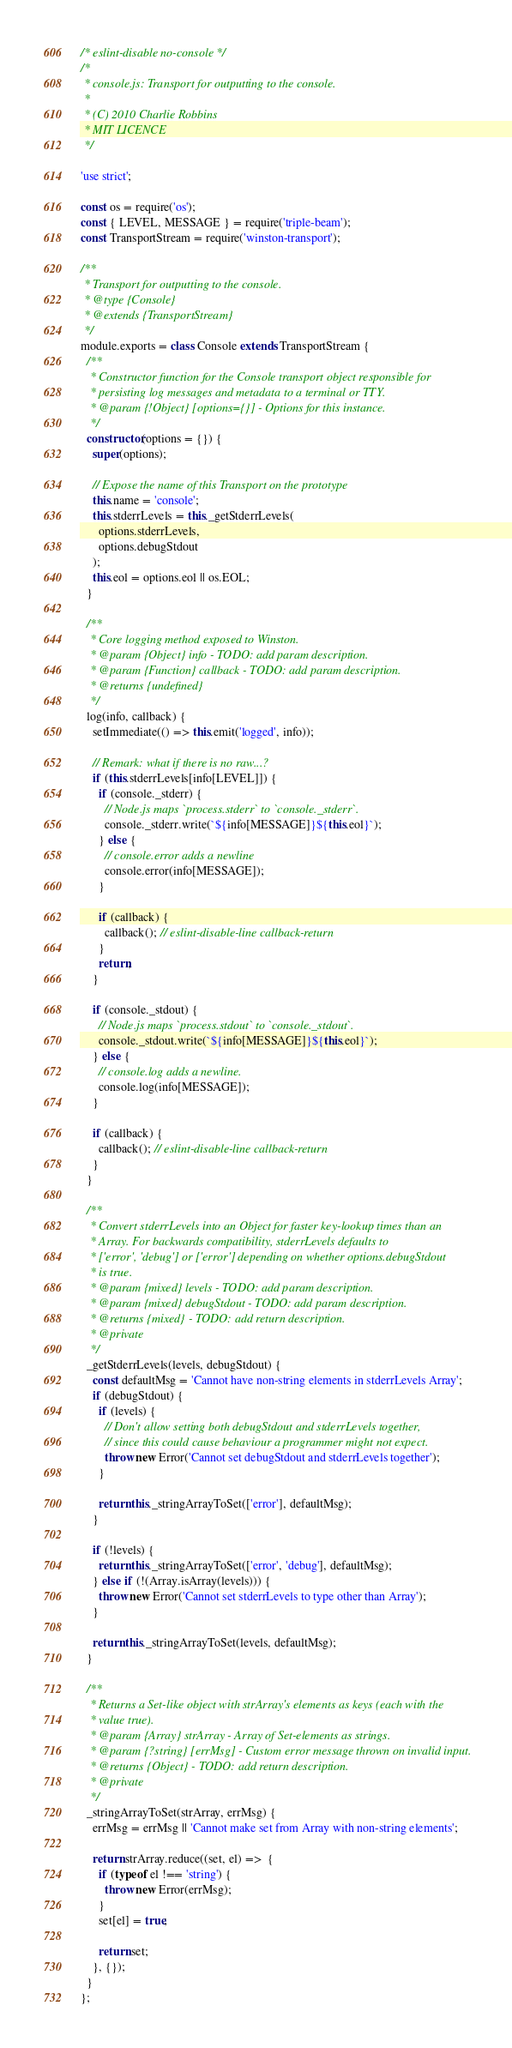<code> <loc_0><loc_0><loc_500><loc_500><_JavaScript_>/* eslint-disable no-console */
/*
 * console.js: Transport for outputting to the console.
 *
 * (C) 2010 Charlie Robbins
 * MIT LICENCE
 */

'use strict';

const os = require('os');
const { LEVEL, MESSAGE } = require('triple-beam');
const TransportStream = require('winston-transport');

/**
 * Transport for outputting to the console.
 * @type {Console}
 * @extends {TransportStream}
 */
module.exports = class Console extends TransportStream {
  /**
   * Constructor function for the Console transport object responsible for
   * persisting log messages and metadata to a terminal or TTY.
   * @param {!Object} [options={}] - Options for this instance.
   */
  constructor(options = {}) {
    super(options);

    // Expose the name of this Transport on the prototype
    this.name = 'console';
    this.stderrLevels = this._getStderrLevels(
      options.stderrLevels,
      options.debugStdout
    );
    this.eol = options.eol || os.EOL;
  }

  /**
   * Core logging method exposed to Winston.
   * @param {Object} info - TODO: add param description.
   * @param {Function} callback - TODO: add param description.
   * @returns {undefined}
   */
  log(info, callback) {
    setImmediate(() => this.emit('logged', info));

    // Remark: what if there is no raw...?
    if (this.stderrLevels[info[LEVEL]]) {
      if (console._stderr) {
        // Node.js maps `process.stderr` to `console._stderr`.
        console._stderr.write(`${info[MESSAGE]}${this.eol}`);
      } else {
        // console.error adds a newline
        console.error(info[MESSAGE]);
      }

      if (callback) {
        callback(); // eslint-disable-line callback-return
      }
      return;
    }

    if (console._stdout) {
      // Node.js maps `process.stdout` to `console._stdout`.
      console._stdout.write(`${info[MESSAGE]}${this.eol}`);
    } else {
      // console.log adds a newline.
      console.log(info[MESSAGE]);
    }

    if (callback) {
      callback(); // eslint-disable-line callback-return
    }
  }

  /**
   * Convert stderrLevels into an Object for faster key-lookup times than an
   * Array. For backwards compatibility, stderrLevels defaults to
   * ['error', 'debug'] or ['error'] depending on whether options.debugStdout
   * is true.
   * @param {mixed} levels - TODO: add param description.
   * @param {mixed} debugStdout - TODO: add param description.
   * @returns {mixed} - TODO: add return description.
   * @private
   */
  _getStderrLevels(levels, debugStdout) {
    const defaultMsg = 'Cannot have non-string elements in stderrLevels Array';
    if (debugStdout) {
      if (levels) {
        // Don't allow setting both debugStdout and stderrLevels together,
        // since this could cause behaviour a programmer might not expect.
        throw new Error('Cannot set debugStdout and stderrLevels together');
      }

      return this._stringArrayToSet(['error'], defaultMsg);
    }

    if (!levels) {
      return this._stringArrayToSet(['error', 'debug'], defaultMsg);
    } else if (!(Array.isArray(levels))) {
      throw new Error('Cannot set stderrLevels to type other than Array');
    }

    return this._stringArrayToSet(levels, defaultMsg);
  }

  /**
   * Returns a Set-like object with strArray's elements as keys (each with the
   * value true).
   * @param {Array} strArray - Array of Set-elements as strings.
   * @param {?string} [errMsg] - Custom error message thrown on invalid input.
   * @returns {Object} - TODO: add return description.
   * @private
   */
  _stringArrayToSet(strArray, errMsg) {
    errMsg = errMsg || 'Cannot make set from Array with non-string elements';

    return strArray.reduce((set, el) =>  {
      if (typeof el !== 'string') {
        throw new Error(errMsg);
      }
      set[el] = true;

      return set;
    }, {});
  }
};
</code> 